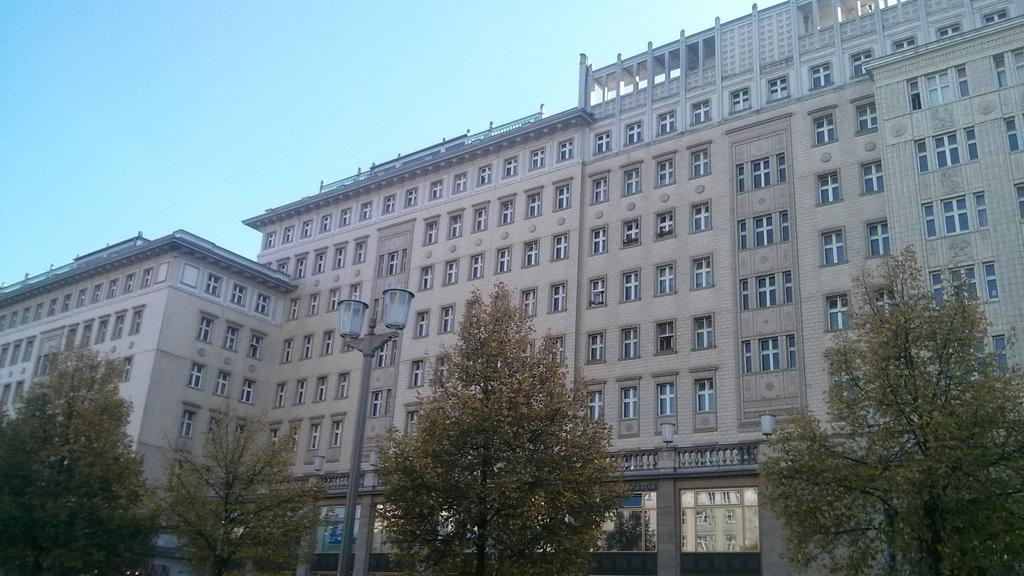What type of structures can be seen in the image? There are buildings in the image. What other elements can be found at the bottom of the image? Many trees and street lights are visible at the bottom of the image. What features do the buildings have? The buildings have windows and doors. What can be seen at the top of the image? The sky is visible at the top of the image. What type of stocking is hanging from the buildings in the image? There is no stocking hanging from the buildings in the image. What type of education is being taught in the buildings in the image? The image does not provide any information about the type of education being taught in the buildings. 